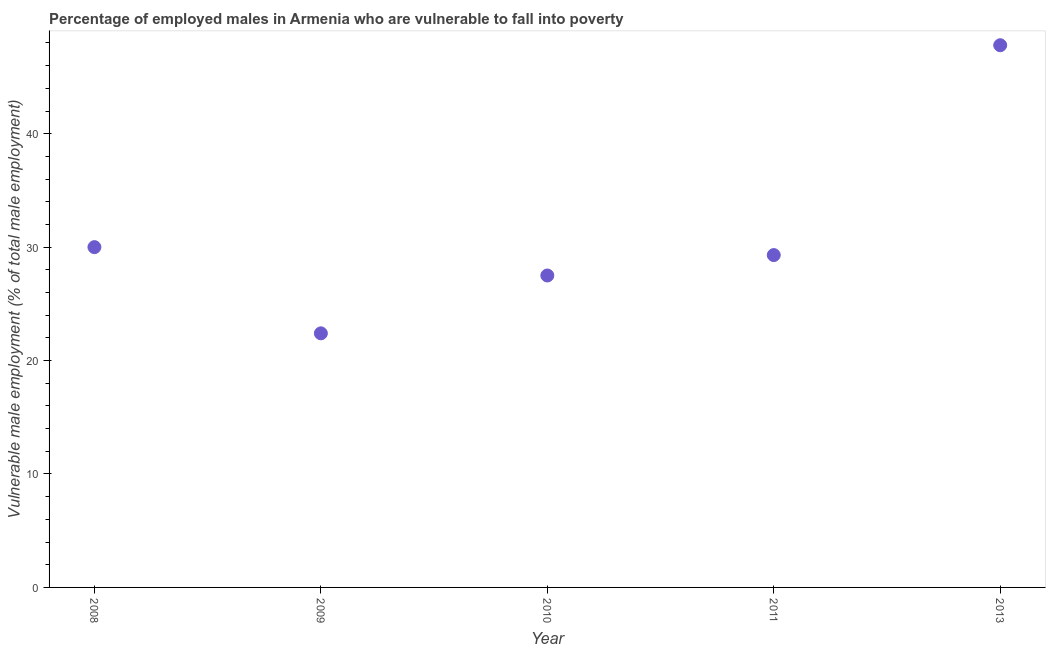What is the percentage of employed males who are vulnerable to fall into poverty in 2013?
Provide a succinct answer. 47.8. Across all years, what is the maximum percentage of employed males who are vulnerable to fall into poverty?
Keep it short and to the point. 47.8. Across all years, what is the minimum percentage of employed males who are vulnerable to fall into poverty?
Offer a terse response. 22.4. In which year was the percentage of employed males who are vulnerable to fall into poverty minimum?
Ensure brevity in your answer.  2009. What is the sum of the percentage of employed males who are vulnerable to fall into poverty?
Your answer should be compact. 157. What is the difference between the percentage of employed males who are vulnerable to fall into poverty in 2009 and 2013?
Provide a succinct answer. -25.4. What is the average percentage of employed males who are vulnerable to fall into poverty per year?
Ensure brevity in your answer.  31.4. What is the median percentage of employed males who are vulnerable to fall into poverty?
Provide a short and direct response. 29.3. What is the ratio of the percentage of employed males who are vulnerable to fall into poverty in 2010 to that in 2013?
Your response must be concise. 0.58. What is the difference between the highest and the second highest percentage of employed males who are vulnerable to fall into poverty?
Your response must be concise. 17.8. Is the sum of the percentage of employed males who are vulnerable to fall into poverty in 2010 and 2013 greater than the maximum percentage of employed males who are vulnerable to fall into poverty across all years?
Offer a terse response. Yes. What is the difference between the highest and the lowest percentage of employed males who are vulnerable to fall into poverty?
Offer a terse response. 25.4. Does the percentage of employed males who are vulnerable to fall into poverty monotonically increase over the years?
Offer a very short reply. No. How many dotlines are there?
Offer a very short reply. 1. How many years are there in the graph?
Give a very brief answer. 5. What is the difference between two consecutive major ticks on the Y-axis?
Offer a very short reply. 10. Does the graph contain any zero values?
Your answer should be very brief. No. Does the graph contain grids?
Offer a very short reply. No. What is the title of the graph?
Provide a succinct answer. Percentage of employed males in Armenia who are vulnerable to fall into poverty. What is the label or title of the X-axis?
Ensure brevity in your answer.  Year. What is the label or title of the Y-axis?
Your answer should be compact. Vulnerable male employment (% of total male employment). What is the Vulnerable male employment (% of total male employment) in 2008?
Your answer should be very brief. 30. What is the Vulnerable male employment (% of total male employment) in 2009?
Your response must be concise. 22.4. What is the Vulnerable male employment (% of total male employment) in 2010?
Your response must be concise. 27.5. What is the Vulnerable male employment (% of total male employment) in 2011?
Keep it short and to the point. 29.3. What is the Vulnerable male employment (% of total male employment) in 2013?
Offer a very short reply. 47.8. What is the difference between the Vulnerable male employment (% of total male employment) in 2008 and 2009?
Offer a very short reply. 7.6. What is the difference between the Vulnerable male employment (% of total male employment) in 2008 and 2010?
Provide a succinct answer. 2.5. What is the difference between the Vulnerable male employment (% of total male employment) in 2008 and 2011?
Offer a terse response. 0.7. What is the difference between the Vulnerable male employment (% of total male employment) in 2008 and 2013?
Provide a short and direct response. -17.8. What is the difference between the Vulnerable male employment (% of total male employment) in 2009 and 2011?
Make the answer very short. -6.9. What is the difference between the Vulnerable male employment (% of total male employment) in 2009 and 2013?
Ensure brevity in your answer.  -25.4. What is the difference between the Vulnerable male employment (% of total male employment) in 2010 and 2011?
Give a very brief answer. -1.8. What is the difference between the Vulnerable male employment (% of total male employment) in 2010 and 2013?
Your answer should be very brief. -20.3. What is the difference between the Vulnerable male employment (% of total male employment) in 2011 and 2013?
Offer a very short reply. -18.5. What is the ratio of the Vulnerable male employment (% of total male employment) in 2008 to that in 2009?
Keep it short and to the point. 1.34. What is the ratio of the Vulnerable male employment (% of total male employment) in 2008 to that in 2010?
Your response must be concise. 1.09. What is the ratio of the Vulnerable male employment (% of total male employment) in 2008 to that in 2011?
Offer a terse response. 1.02. What is the ratio of the Vulnerable male employment (% of total male employment) in 2008 to that in 2013?
Provide a short and direct response. 0.63. What is the ratio of the Vulnerable male employment (% of total male employment) in 2009 to that in 2010?
Your response must be concise. 0.81. What is the ratio of the Vulnerable male employment (% of total male employment) in 2009 to that in 2011?
Ensure brevity in your answer.  0.77. What is the ratio of the Vulnerable male employment (% of total male employment) in 2009 to that in 2013?
Give a very brief answer. 0.47. What is the ratio of the Vulnerable male employment (% of total male employment) in 2010 to that in 2011?
Offer a very short reply. 0.94. What is the ratio of the Vulnerable male employment (% of total male employment) in 2010 to that in 2013?
Keep it short and to the point. 0.57. What is the ratio of the Vulnerable male employment (% of total male employment) in 2011 to that in 2013?
Give a very brief answer. 0.61. 